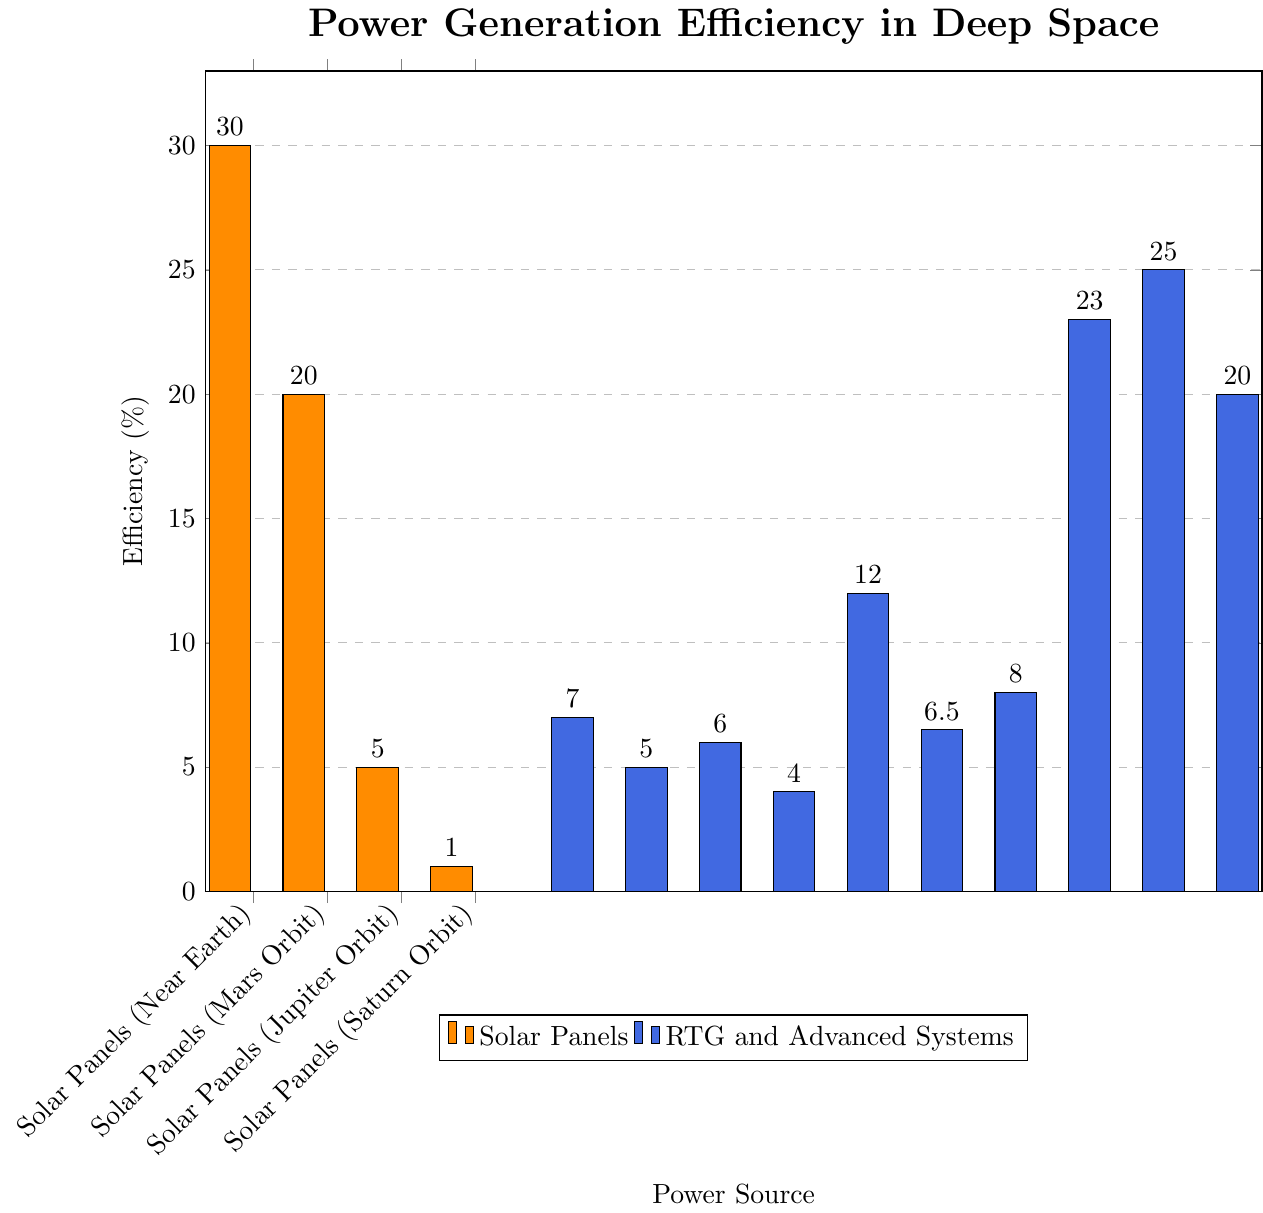What is the efficiency difference between Solar Panels (Near Earth) and Solar Panels (Mars Orbit)? Look at the height of the bars for Solar Panels (Near Earth) and Solar Panels (Mars Orbit). Solar Panels (Near Earth) have an efficiency of 30%, and Solar Panels (Mars Orbit) have an efficiency of 20%. Subtract the two values: 30% - 20% = 10%.
Answer: 10% Which power source has the highest efficiency in the figure? Scan all the bars to identify the one with the greatest height. The Dynamic Isotope Power System has the highest efficiency at 25%.
Answer: Dynamic Isotope Power System How does the efficiency of Solar Panels (Saturn Orbit) compare to RTG (Plutonium-238)? Look at the heights of the bars for Solar Panels (Saturn Orbit) and RTG (Plutonium-238). Solar Panels (Saturn Orbit) have an efficiency of 1%, whereas RTG (Plutonium-238) has an efficiency of 7%. Therefore, RTG (Plutonium-238) has a higher efficiency.
Answer: RTG (Plutonium-238) What is the average efficiency of all the RTG systems (excluding advanced and dynamic systems)? List all the efficiencies of RTG systems: Plutonium-238 (7%), Americium-241 (5%), Curium-244 (6%), Strontium-90 (4%), Multi-Mission RTG (6.5%), Enhanced MMRTG (8%). Sum these values: 7 + 5 + 6 + 4 + 6.5 + 8 = 36.5. Count the number of RTG systems, which is 6. Divide the total sum by the number of systems: 36.5 / 6 = 6.08%.
Answer: 6.08% What is the color associated with the bars representing RTG and advanced systems? Observe the legend of the figure to identify the color assignment. The RTG and advanced systems are represented by blue bars.
Answer: Blue Which advanced system has an efficiency closest to Solar Panels (Mars Orbit)? Solar Panels (Mars Orbit) have an efficiency of 20%. Compare this with the efficiencies of advanced systems: Advanced RTG (12%), Stirling Radioisotope Generator (23%), Dynamic Isotope Power System (25%), and Alkali Metal Thermal Electric Converter (20%). The Alkali Metal Thermal Electric Converter has an efficiency of 20%, which is closest or equal to Solar Panels (Mars Orbit).
Answer: Alkali Metal Thermal Electric Converter What is the combined efficiency of all the solar panel systems? List all the efficiencies of solar panel systems: Near Earth (30%), Mars Orbit (20%), Jupiter Orbit (5%), Saturn Orbit (1%). Sum these values: 30 + 20 + 5 + 1 = 56%.
Answer: 56% What is the ratio of the efficiency of the Stirling Radioisotope Generator to that of RTG (Curium-244)? Stirling Radioisotope Generator has an efficiency of 23%, and RTG (Curium-244) has an efficiency of 6%. Divide the efficiency of the Stirling Radioisotope Generator by the efficiency of RTG (Curium-244): 23 / 6 = 3.83.
Answer: 3.83 How many power sources have an efficiency greater than 20%? Scan all the efficiency values and count those greater than 20%: Solar Panels (Near Earth) at 30%, Stirling Radioisotope Generator at 23%, Dynamic Isotope Power System at 25%, Alkali Metal Thermal Electric Converter at 20% (excluded). This leaves three power sources with efficiencies greater than 20%.
Answer: 3 